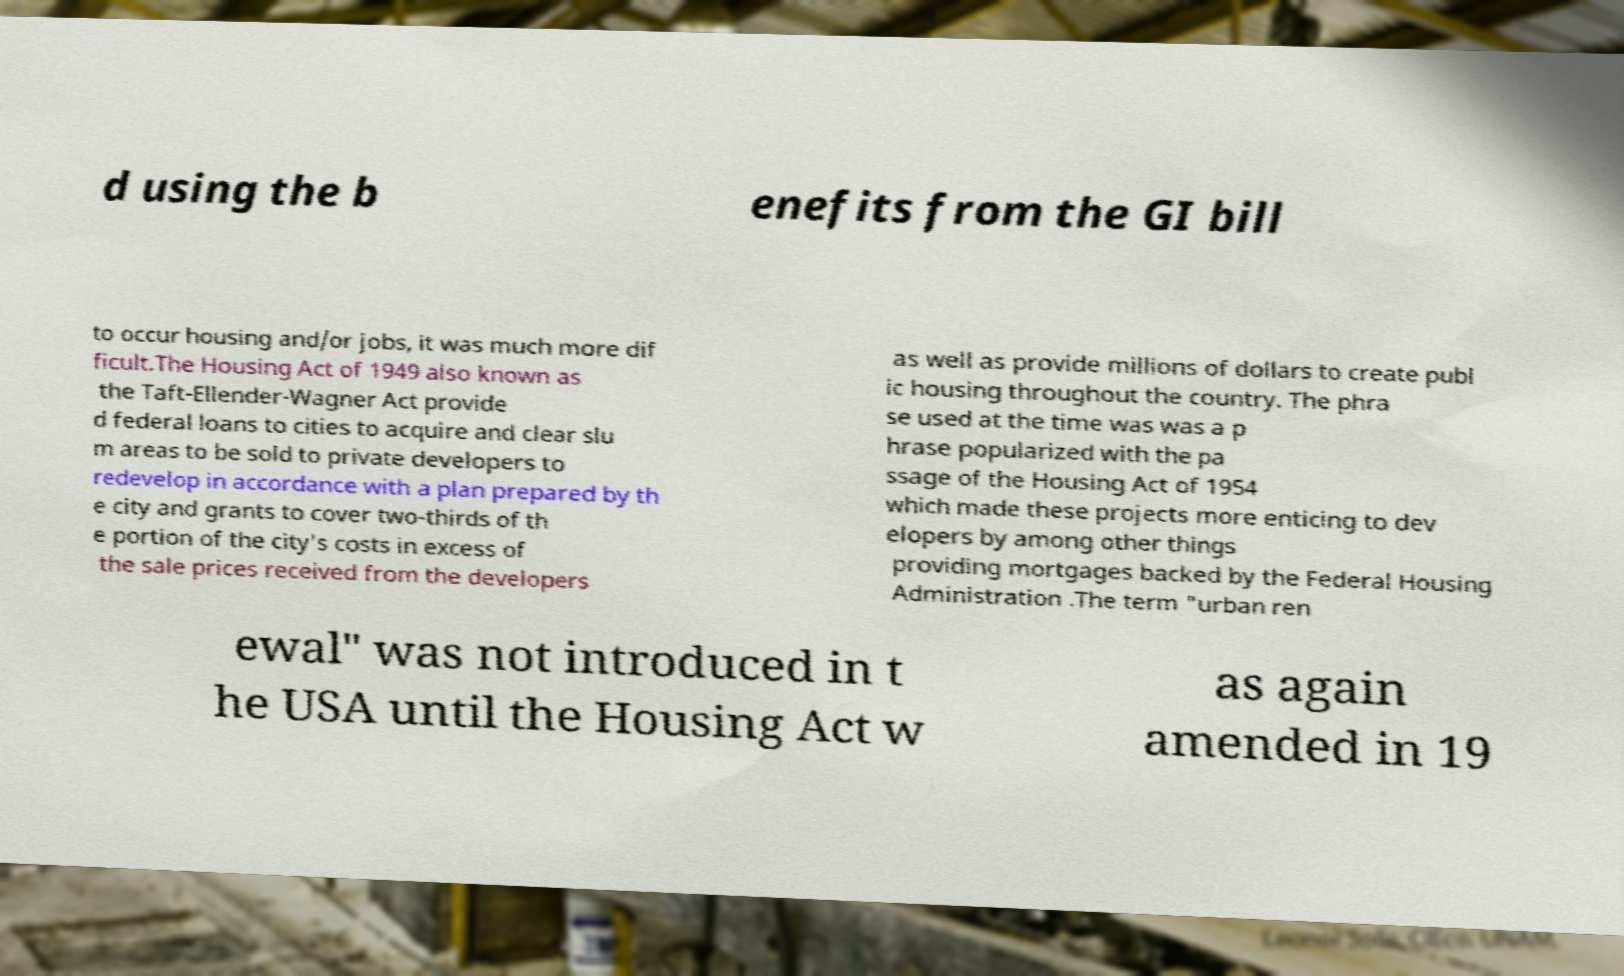Could you assist in decoding the text presented in this image and type it out clearly? d using the b enefits from the GI bill to occur housing and/or jobs, it was much more dif ficult.The Housing Act of 1949 also known as the Taft-Ellender-Wagner Act provide d federal loans to cities to acquire and clear slu m areas to be sold to private developers to redevelop in accordance with a plan prepared by th e city and grants to cover two-thirds of th e portion of the city's costs in excess of the sale prices received from the developers as well as provide millions of dollars to create publ ic housing throughout the country. The phra se used at the time was was a p hrase popularized with the pa ssage of the Housing Act of 1954 which made these projects more enticing to dev elopers by among other things providing mortgages backed by the Federal Housing Administration .The term "urban ren ewal" was not introduced in t he USA until the Housing Act w as again amended in 19 